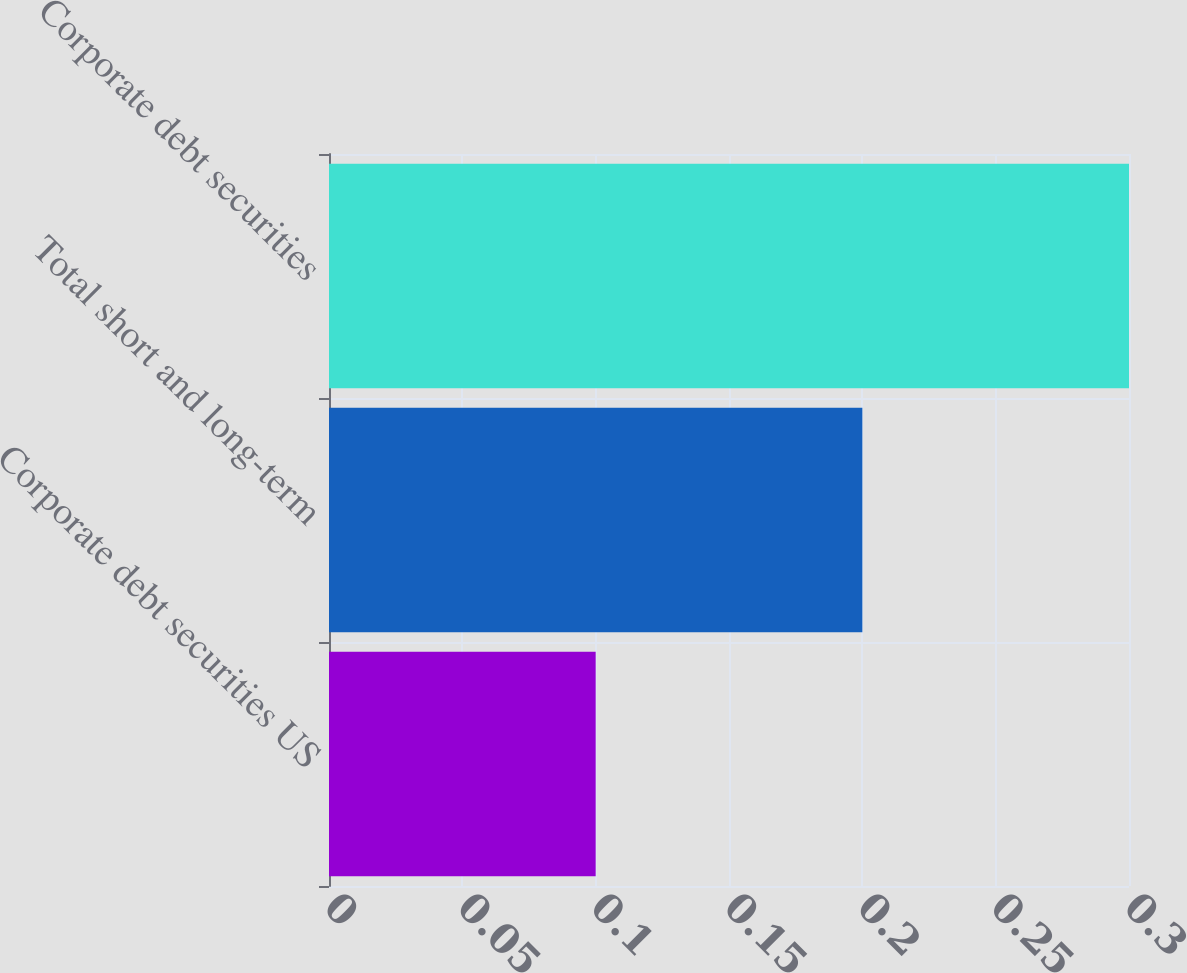<chart> <loc_0><loc_0><loc_500><loc_500><bar_chart><fcel>Corporate debt securities US<fcel>Total short and long-term<fcel>Corporate debt securities<nl><fcel>0.1<fcel>0.2<fcel>0.3<nl></chart> 